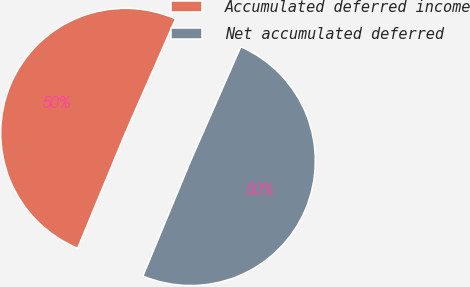Convert chart. <chart><loc_0><loc_0><loc_500><loc_500><pie_chart><fcel>Accumulated deferred income<fcel>Net accumulated deferred<nl><fcel>50.34%<fcel>49.66%<nl></chart> 